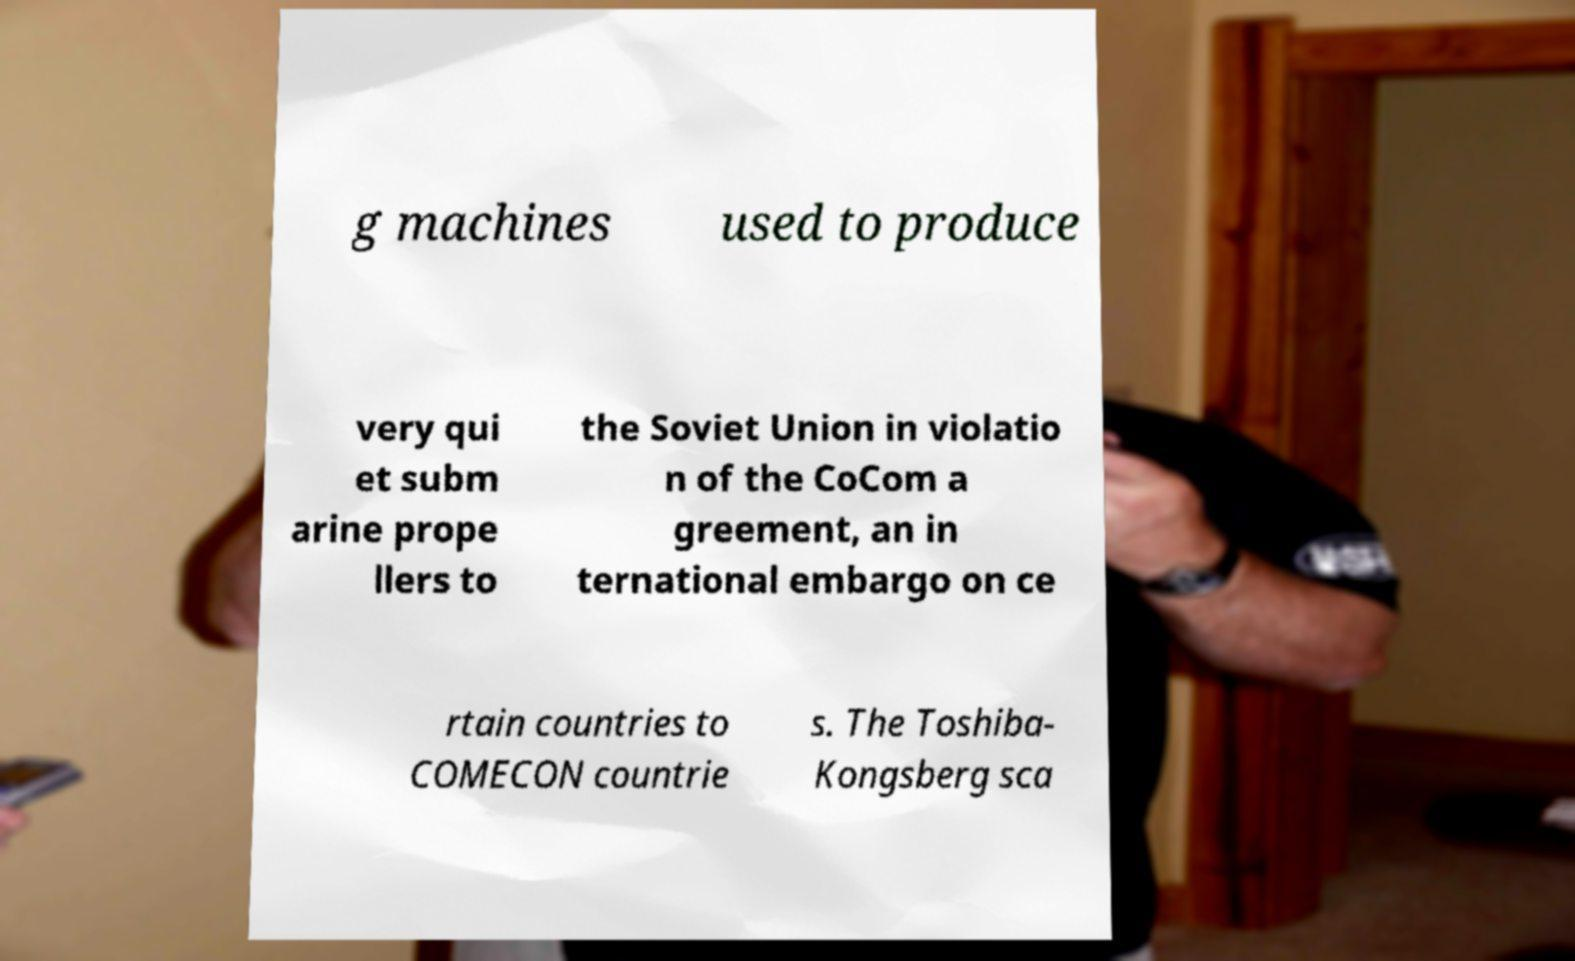I need the written content from this picture converted into text. Can you do that? g machines used to produce very qui et subm arine prope llers to the Soviet Union in violatio n of the CoCom a greement, an in ternational embargo on ce rtain countries to COMECON countrie s. The Toshiba- Kongsberg sca 